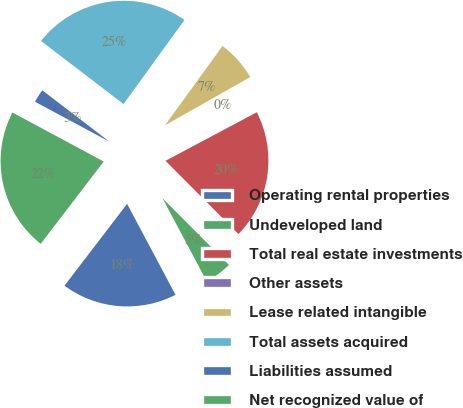Convert chart. <chart><loc_0><loc_0><loc_500><loc_500><pie_chart><fcel>Operating rental properties<fcel>Undeveloped land<fcel>Total real estate investments<fcel>Other assets<fcel>Lease related intangible<fcel>Total assets acquired<fcel>Liabilities assumed<fcel>Net recognized value of<nl><fcel>18.18%<fcel>4.68%<fcel>20.32%<fcel>0.41%<fcel>6.82%<fcel>24.59%<fcel>2.55%<fcel>22.45%<nl></chart> 